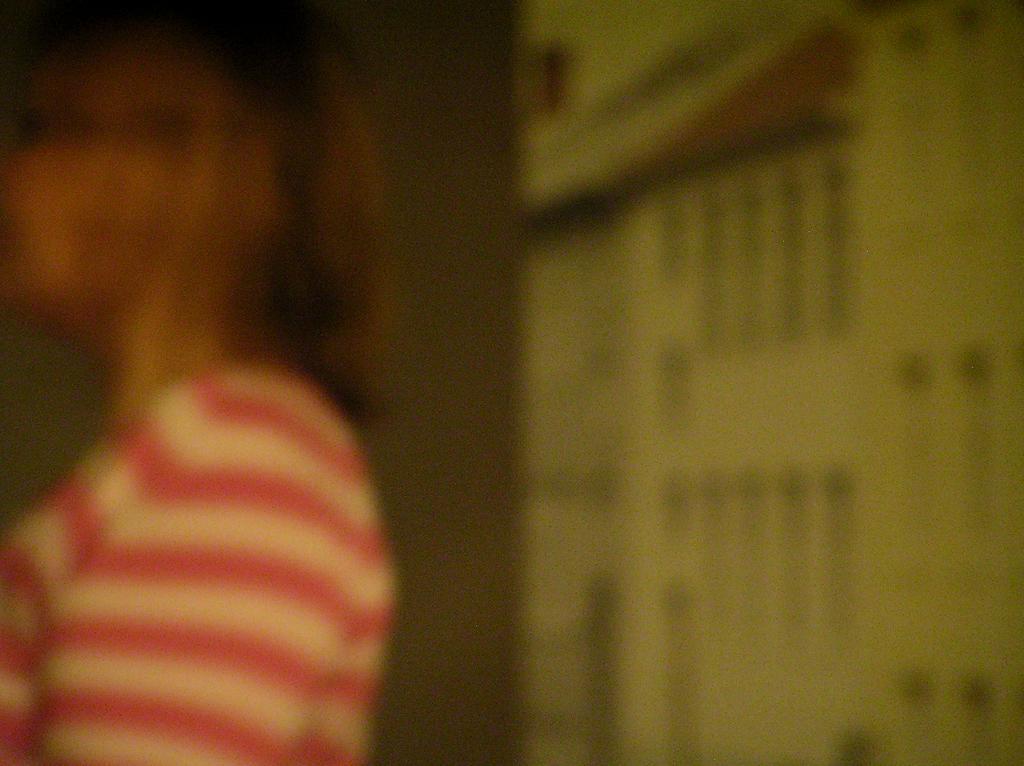Can you describe this image briefly? This is a blurry image. There is a woman in the image. 